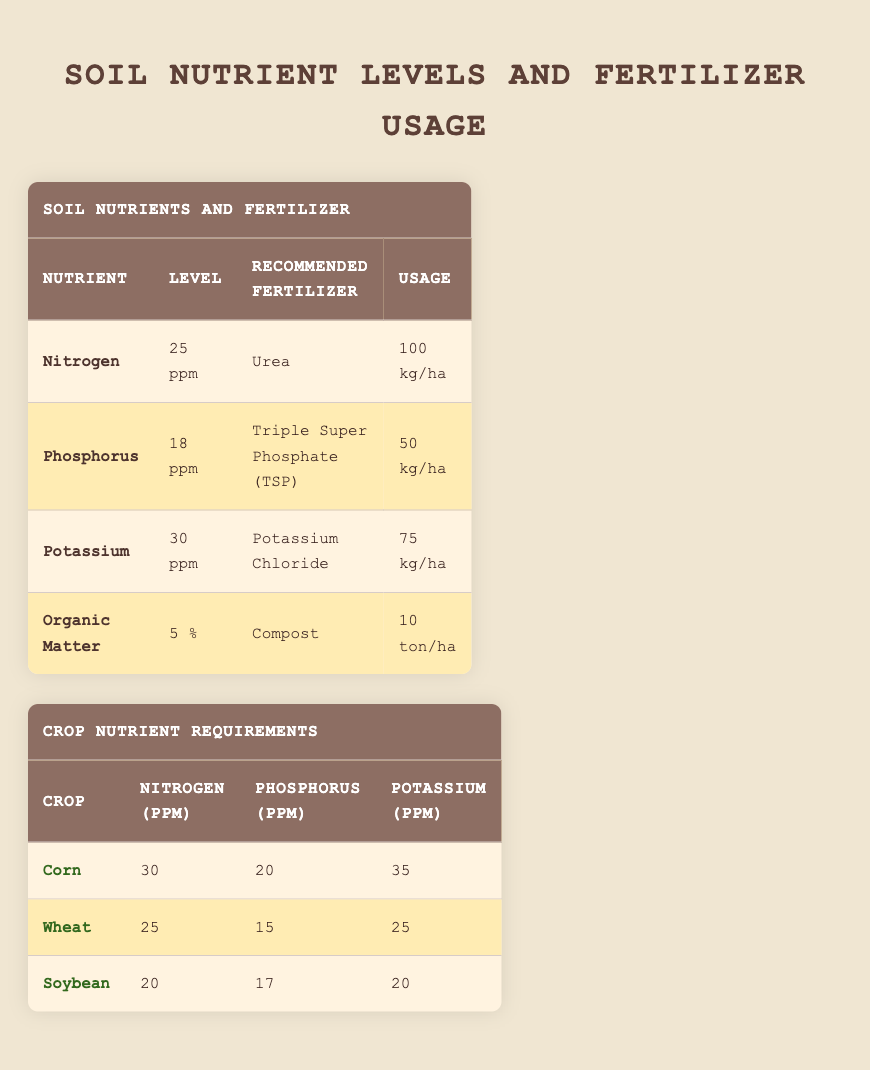What is the recommended fertilizer for Nitrogen? The table lists the recommended fertilizer for Nitrogen as Urea under the Soil Nutrients and Fertilizer section.
Answer: Urea What is the level of Potassium in the soil? The table indicates that the level of Potassium is 30 ppm in the corresponding row under Soil Nutrients and Fertilizer.
Answer: 30 ppm Does Corn require more Potassium than Wheat? According to the Crop Nutrient Requirements section, Corn requires 35 ppm of Potassium, while Wheat requires 25 ppm. Since 35 is greater than 25, the statement is true.
Answer: Yes What is the total recommended fertilizer usage for Nitrogen and Phosphorus combined? The recommended fertilizer usage for Nitrogen is 100 kg/ha and for Phosphorus is 50 kg/ha. Therefore, the total usage is calculated by adding these two values: 100 + 50 = 150 kg/ha.
Answer: 150 kg/ha Is the organic matter level sufficient for any crop listed? The organic matter level is 5%. For Corn, it may be sufficient since Corn does require high fertility. However, it would be beneficial to assess needing additional organic matter against crop requirements as it's generally advisable to have higher organic matter levels for optimal growth, leading to a general conclusion that it may not suffice alone.
Answer: No 